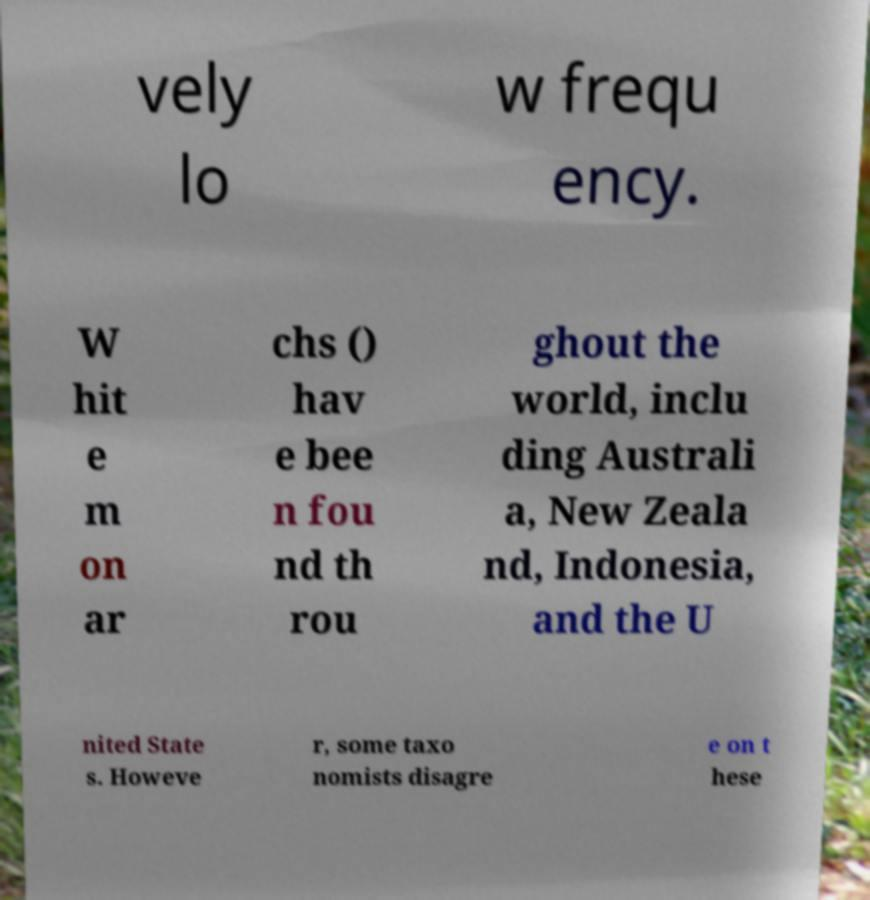I need the written content from this picture converted into text. Can you do that? vely lo w frequ ency. W hit e m on ar chs () hav e bee n fou nd th rou ghout the world, inclu ding Australi a, New Zeala nd, Indonesia, and the U nited State s. Howeve r, some taxo nomists disagre e on t hese 